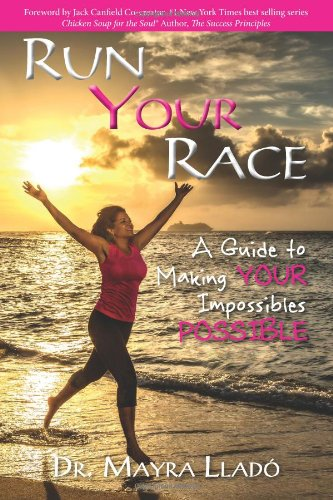How can this book contribute to my personal development? This book, as a resource in the Self-Help genre, provides strategies and insights to motivate you towards realizing what might seem impossible. By using practical examples and motivational language, it equips you to pursue personal growth and self-fulfillment. 